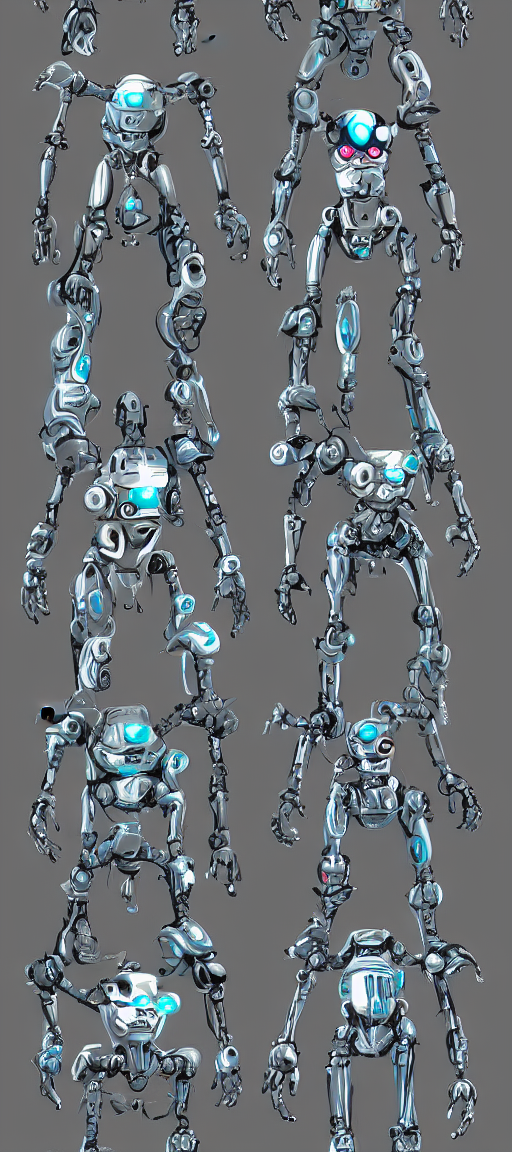What emotions or characteristics do the different poses of the robots convey? The varied poses of the robots convey a range of potential characteristics and states of 'mind.' Some poses suggest readiness and alertness, while others exhibit curiosity, as if they're exploring or interacting with their environment. A few stances appear playful, perhaps mimicking human behavior, which might be utilized in social robotics to make them more relatable and engaging when interacting with people. 